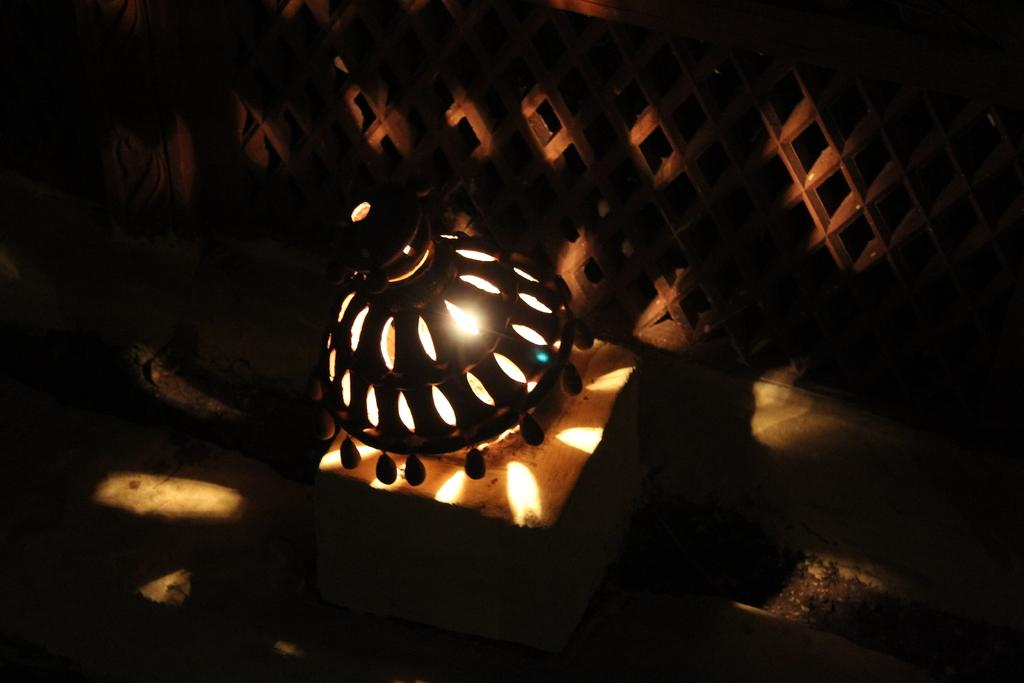What is the main object in the center of the image? There is a table in the center of the image. What type of lighting fixture is present in the image? There is a roof hanging lamp in the image. Can you describe the lighting in the image? Lights are present in the image. What can be seen in the background of the image? There is a wall and a window in the background of the image. Are there any other objects visible in the image? Yes, there are a few other objects in the image. What type of shirt is the scene wearing in the image? There is no scene or person wearing a shirt in the image; it is an interior scene with a table, a roof hanging lamp, lights, a wall, a window, and a few other objects. 